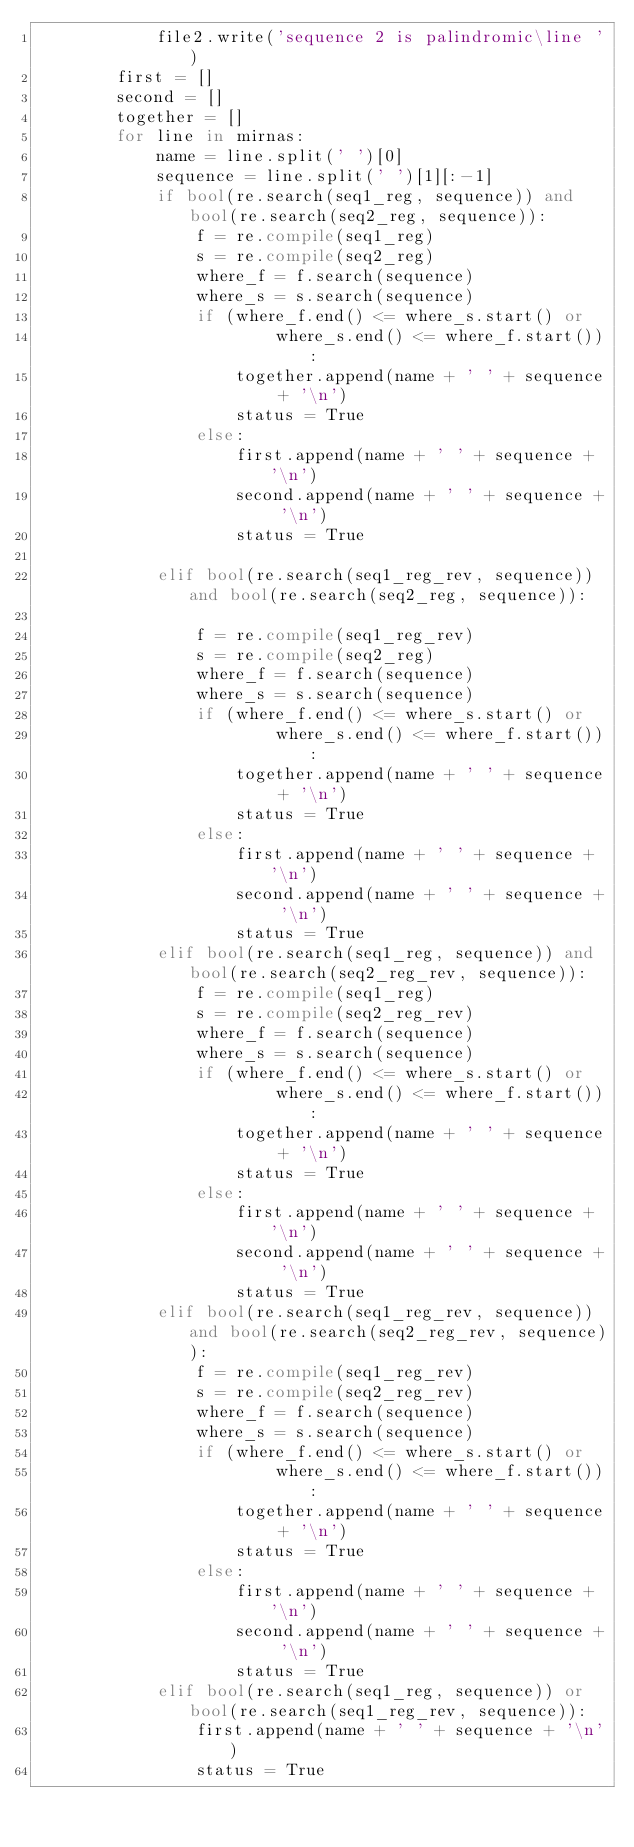Convert code to text. <code><loc_0><loc_0><loc_500><loc_500><_Python_>            file2.write('sequence 2 is palindromic\line ')
        first = []
        second = []
        together = []
        for line in mirnas:
            name = line.split(' ')[0]
            sequence = line.split(' ')[1][:-1]
            if bool(re.search(seq1_reg, sequence)) and bool(re.search(seq2_reg, sequence)):
                f = re.compile(seq1_reg)
                s = re.compile(seq2_reg)
                where_f = f.search(sequence)
                where_s = s.search(sequence)
                if (where_f.end() <= where_s.start() or
                        where_s.end() <= where_f.start()):
                    together.append(name + ' ' + sequence + '\n')
                    status = True
                else:
                    first.append(name + ' ' + sequence + '\n')
                    second.append(name + ' ' + sequence + '\n')
                    status = True

            elif bool(re.search(seq1_reg_rev, sequence)) and bool(re.search(seq2_reg, sequence)):

                f = re.compile(seq1_reg_rev)
                s = re.compile(seq2_reg)
                where_f = f.search(sequence)
                where_s = s.search(sequence)
                if (where_f.end() <= where_s.start() or
                        where_s.end() <= where_f.start()):
                    together.append(name + ' ' + sequence + '\n')
                    status = True
                else:
                    first.append(name + ' ' + sequence + '\n')
                    second.append(name + ' ' + sequence + '\n')
                    status = True
            elif bool(re.search(seq1_reg, sequence)) and bool(re.search(seq2_reg_rev, sequence)):
                f = re.compile(seq1_reg)
                s = re.compile(seq2_reg_rev)
                where_f = f.search(sequence)
                where_s = s.search(sequence)
                if (where_f.end() <= where_s.start() or
                        where_s.end() <= where_f.start()):
                    together.append(name + ' ' + sequence + '\n')
                    status = True
                else:
                    first.append(name + ' ' + sequence + '\n')
                    second.append(name + ' ' + sequence + '\n')
                    status = True
            elif bool(re.search(seq1_reg_rev, sequence)) and bool(re.search(seq2_reg_rev, sequence)):
                f = re.compile(seq1_reg_rev)
                s = re.compile(seq2_reg_rev)
                where_f = f.search(sequence)
                where_s = s.search(sequence)
                if (where_f.end() <= where_s.start() or
                        where_s.end() <= where_f.start()):
                    together.append(name + ' ' + sequence + '\n')
                    status = True
                else:
                    first.append(name + ' ' + sequence + '\n')
                    second.append(name + ' ' + sequence + '\n')
                    status = True
            elif bool(re.search(seq1_reg, sequence)) or bool(re.search(seq1_reg_rev, sequence)):
                first.append(name + ' ' + sequence + '\n')
                status = True</code> 